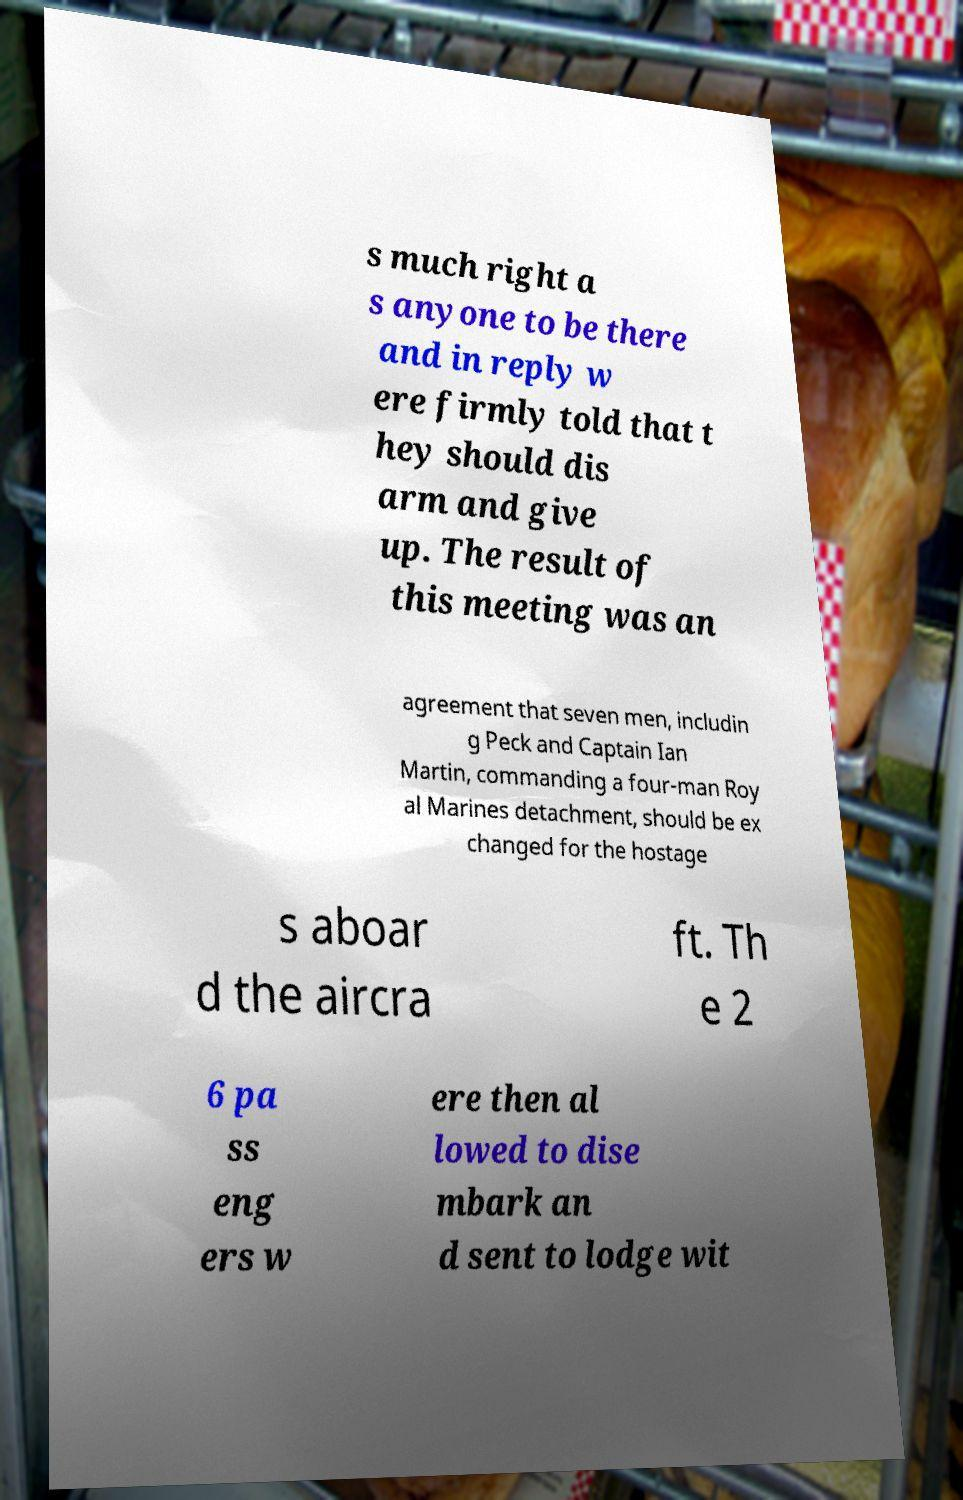Could you assist in decoding the text presented in this image and type it out clearly? s much right a s anyone to be there and in reply w ere firmly told that t hey should dis arm and give up. The result of this meeting was an agreement that seven men, includin g Peck and Captain Ian Martin, commanding a four-man Roy al Marines detachment, should be ex changed for the hostage s aboar d the aircra ft. Th e 2 6 pa ss eng ers w ere then al lowed to dise mbark an d sent to lodge wit 